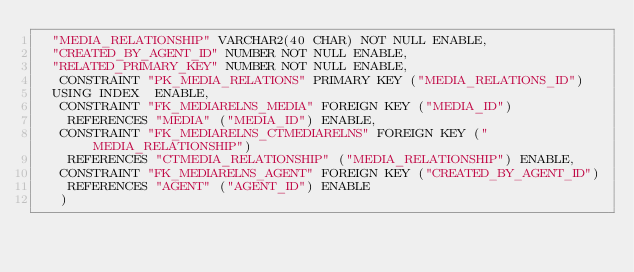Convert code to text. <code><loc_0><loc_0><loc_500><loc_500><_SQL_>	"MEDIA_RELATIONSHIP" VARCHAR2(40 CHAR) NOT NULL ENABLE, 
	"CREATED_BY_AGENT_ID" NUMBER NOT NULL ENABLE, 
	"RELATED_PRIMARY_KEY" NUMBER NOT NULL ENABLE, 
	 CONSTRAINT "PK_MEDIA_RELATIONS" PRIMARY KEY ("MEDIA_RELATIONS_ID")
  USING INDEX  ENABLE, 
	 CONSTRAINT "FK_MEDIARELNS_MEDIA" FOREIGN KEY ("MEDIA_ID")
	  REFERENCES "MEDIA" ("MEDIA_ID") ENABLE, 
	 CONSTRAINT "FK_MEDIARELNS_CTMEDIARELNS" FOREIGN KEY ("MEDIA_RELATIONSHIP")
	  REFERENCES "CTMEDIA_RELATIONSHIP" ("MEDIA_RELATIONSHIP") ENABLE, 
	 CONSTRAINT "FK_MEDIARELNS_AGENT" FOREIGN KEY ("CREATED_BY_AGENT_ID")
	  REFERENCES "AGENT" ("AGENT_ID") ENABLE
   ) </code> 